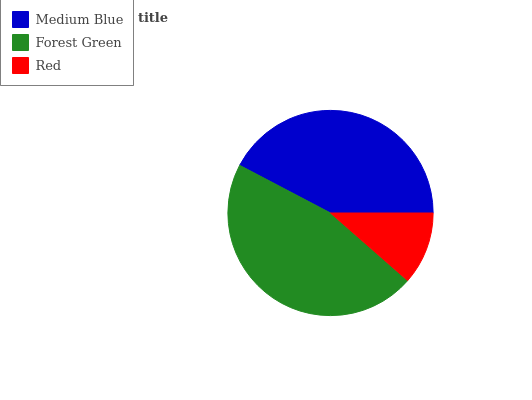Is Red the minimum?
Answer yes or no. Yes. Is Forest Green the maximum?
Answer yes or no. Yes. Is Forest Green the minimum?
Answer yes or no. No. Is Red the maximum?
Answer yes or no. No. Is Forest Green greater than Red?
Answer yes or no. Yes. Is Red less than Forest Green?
Answer yes or no. Yes. Is Red greater than Forest Green?
Answer yes or no. No. Is Forest Green less than Red?
Answer yes or no. No. Is Medium Blue the high median?
Answer yes or no. Yes. Is Medium Blue the low median?
Answer yes or no. Yes. Is Red the high median?
Answer yes or no. No. Is Forest Green the low median?
Answer yes or no. No. 